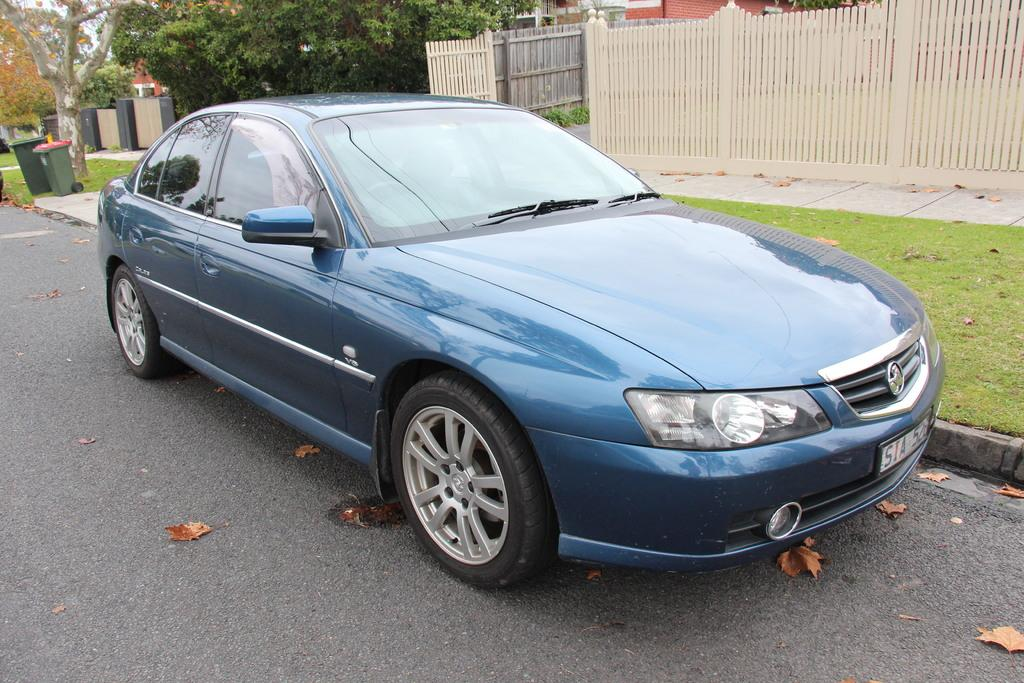What is the main subject of the image? There is a car on the road in the image. What can be seen in the background of the image? In the background of the image, there is a fence, grass, dustbins, trees, and a house. Can you describe the environment surrounding the car? The car is surrounded by a fence, grass, and trees in the background. What type of structures are visible in the background? A house and dustbins are visible in the background. Where is the throne located in the image? There is no throne present in the image. What type of plants can be seen growing near the car in the image? The image does not show any plants growing near the car; it only shows a fence, grass, and trees in the background. 